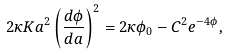Convert formula to latex. <formula><loc_0><loc_0><loc_500><loc_500>2 \kappa K a ^ { 2 } \left ( \frac { d \phi } { d a } \right ) ^ { 2 } = 2 \kappa \phi _ { 0 } - C ^ { 2 } e ^ { - 4 \phi } ,</formula> 